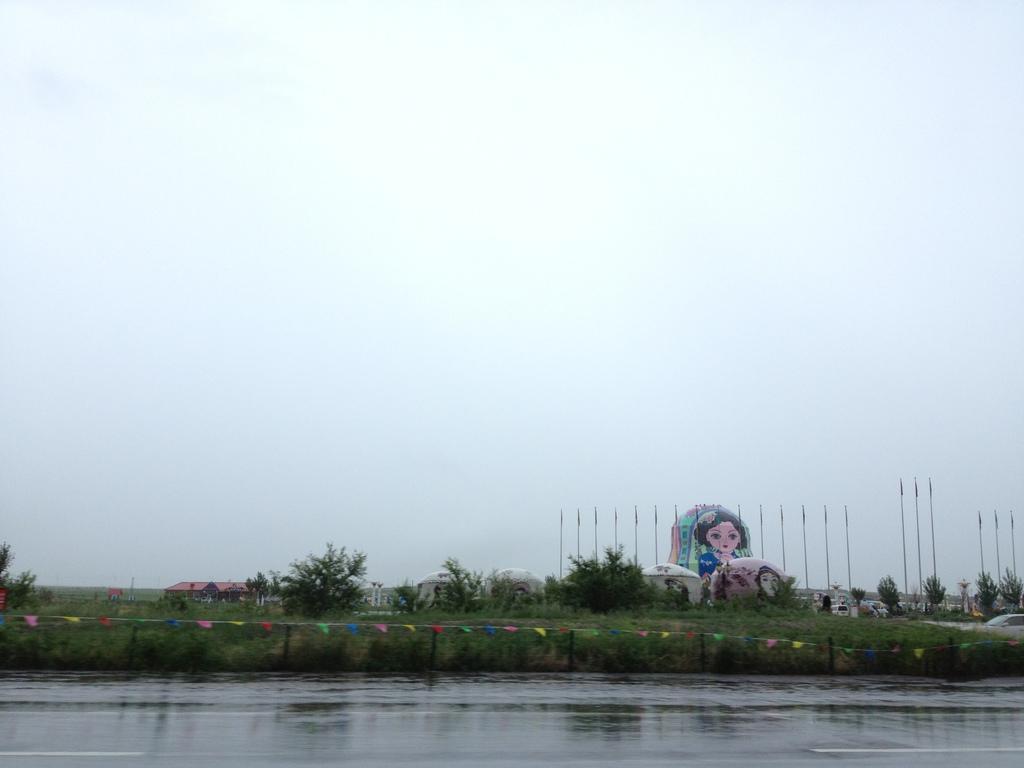How would you summarize this image in a sentence or two? In this picture, we can see water, ground, poles, trees, grass, small flags, and some art on objects, houses, and the sky. 